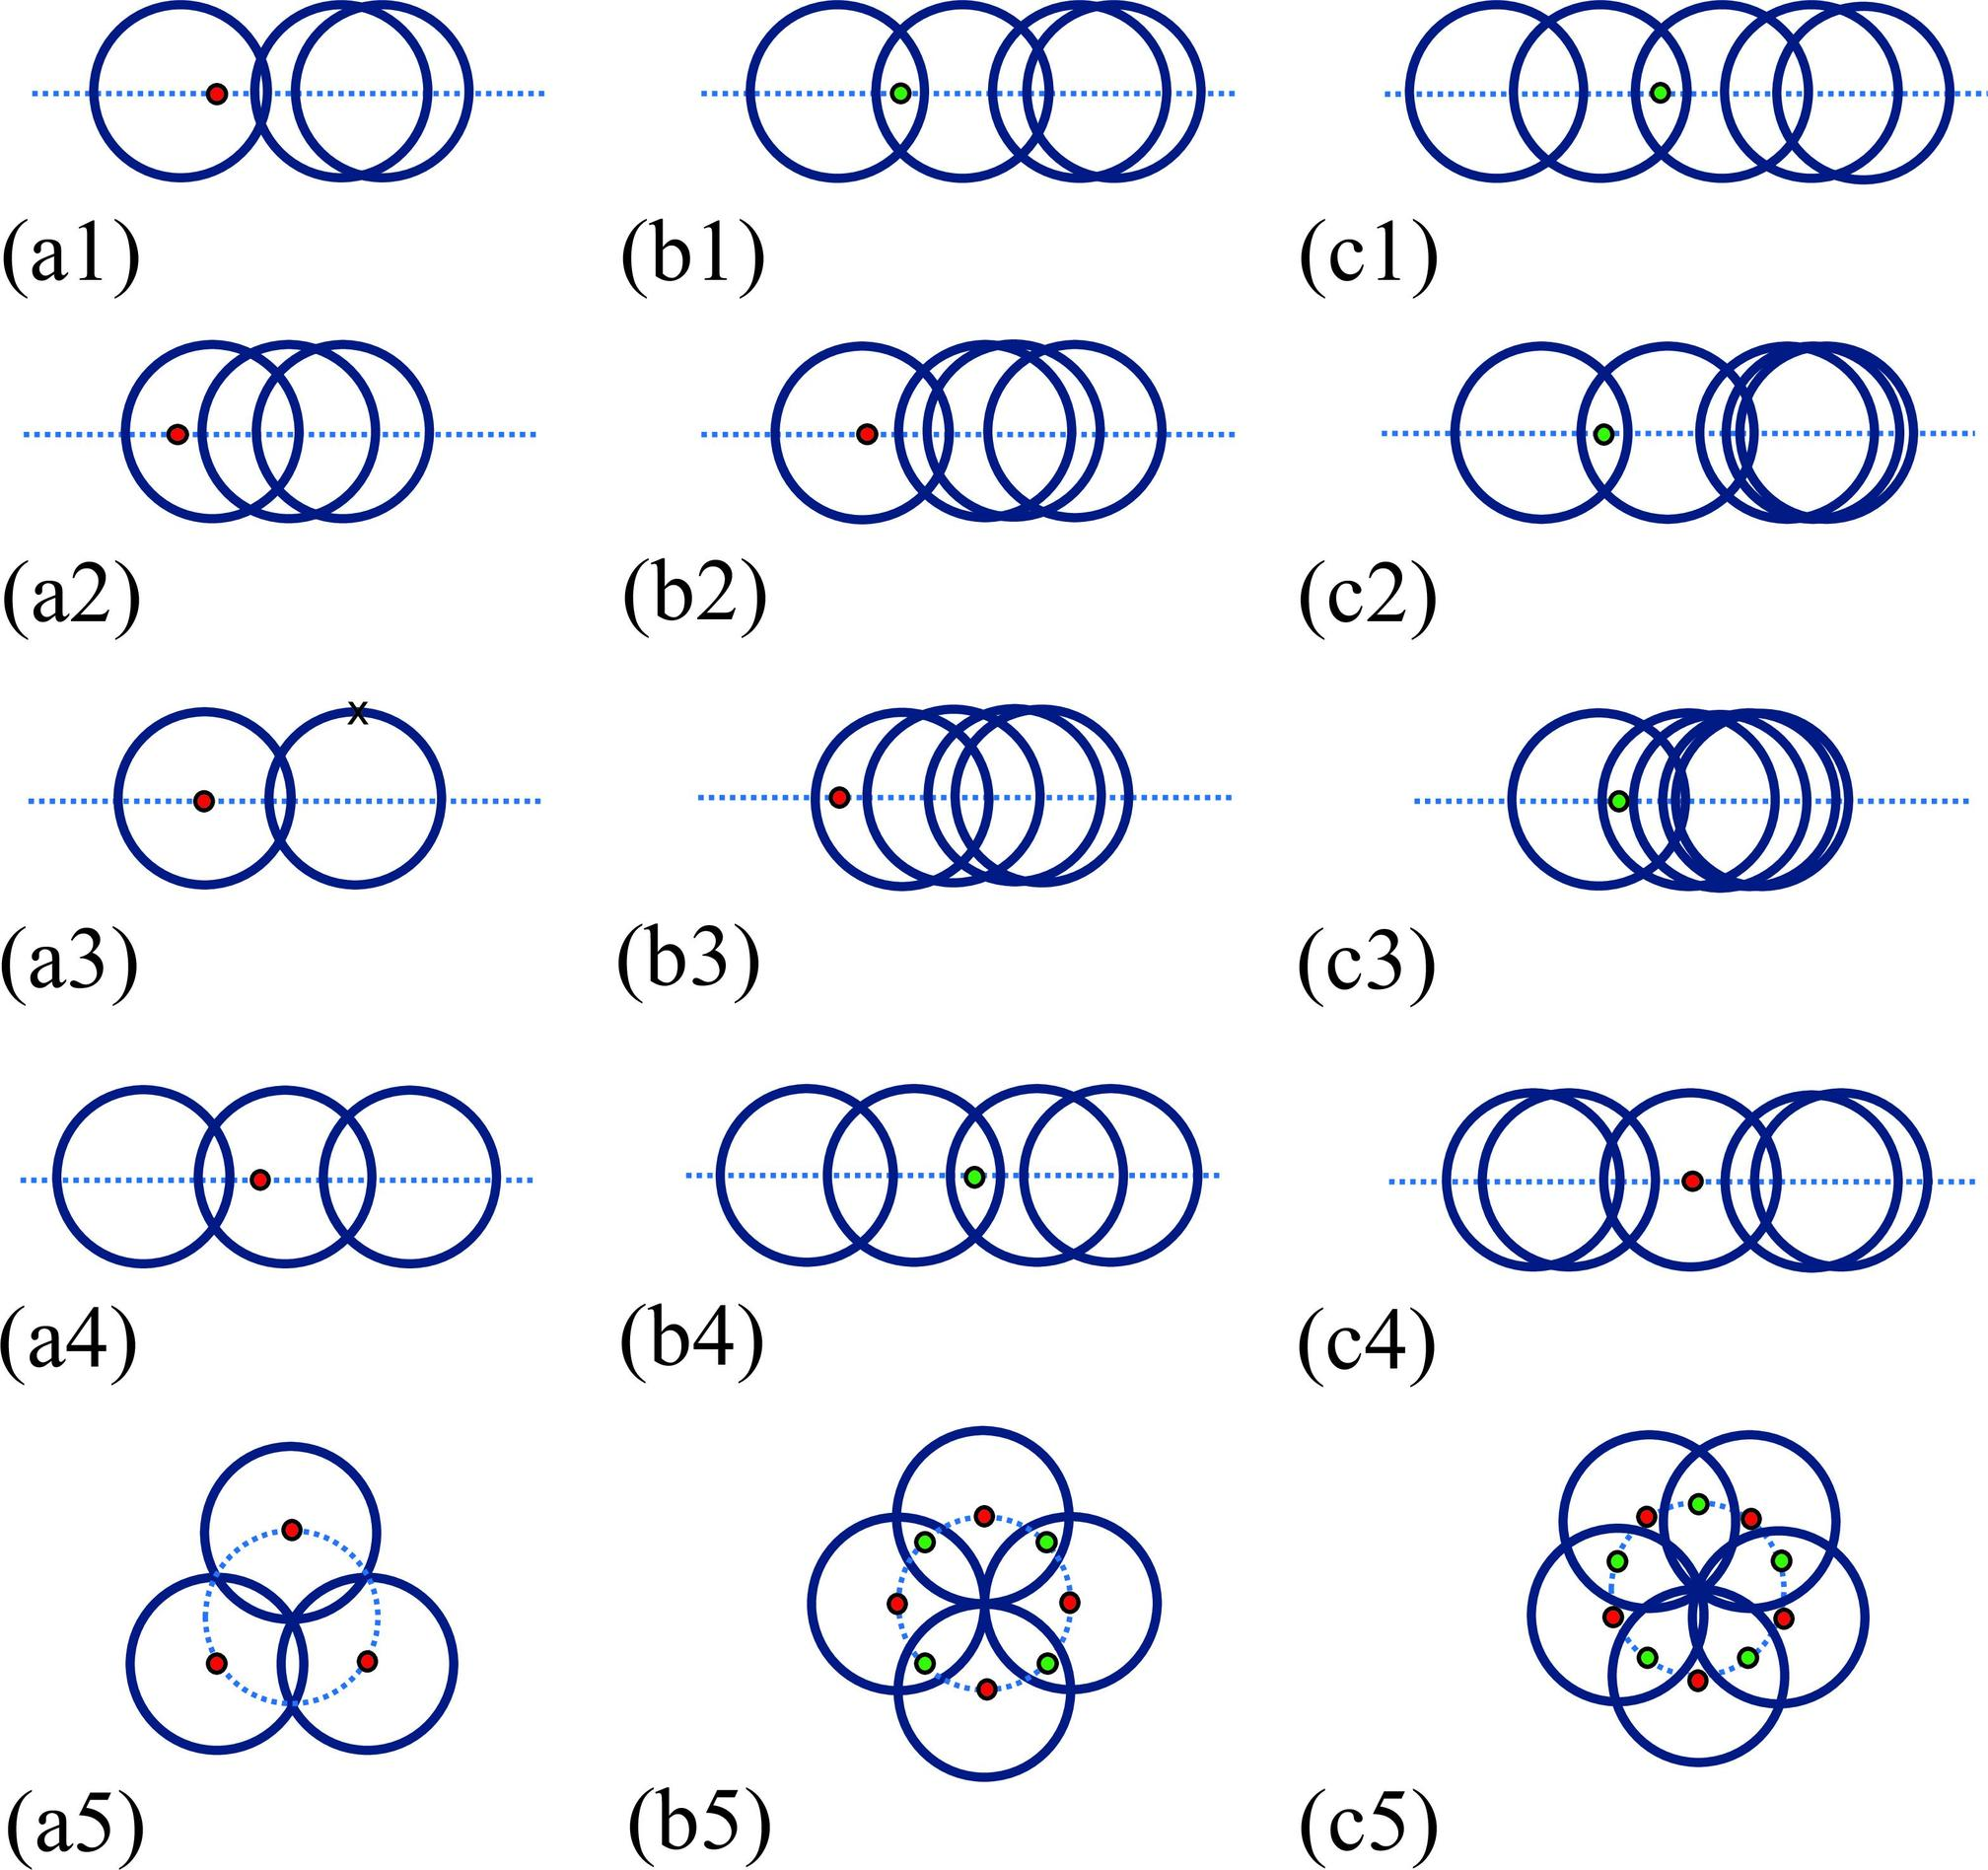Based on figures c1 to c3, what is the role of the blue circles in relation to the red and green dots? A. The blue circles are generating the dots. B. The blue circles are moving independently of the dots. C. The blue circles are controlling the movement of the dots. D. The blue circles and dots are part of a feedback loop. The diagrams in figures c1 to c3 depict blue circles surrounding red and green dots. Analyzing their arrangement and interaction suggests a dynamic relationship akin to a feedback loop. This is where each set of elements influences the other's behavior. The blue circles seem to be positioned strategically around the dots, implying a controlling or regulatory role, but not in a way that suggests independent movement or generation of the dots. Therefore, the most accurate interpretation would be that they are part of a feedback loop, interacting and impacting one another continuously. 